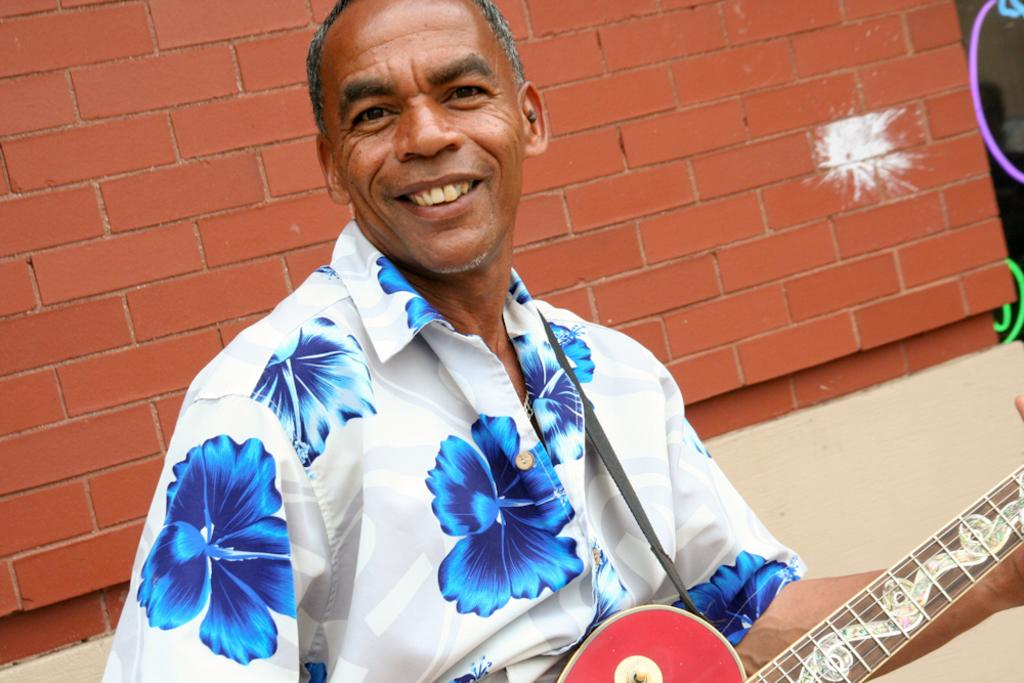Who is in the image? There is a man in the image. What is the man holding in the image? The man is holding a guitar. What expression does the man have in the image? The man is smiling. What is the man wearing in the image? The man is wearing a shirt with a blue color flowers design. What can be seen in the background of the image? There is a brick wall in the background of the image. What type of drug is the man using in the image? There is no indication of any drug use in the image; the man is holding a guitar and smiling. 